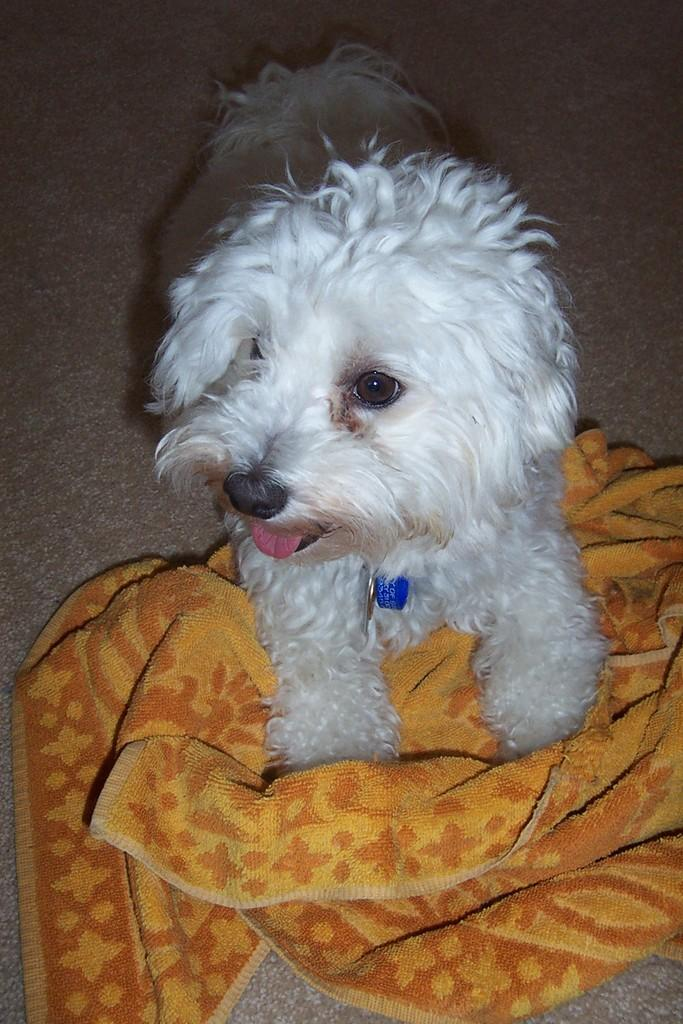What type of animal is present in the image? There is a dog in the image. What type of material is visible in the image? There is cloth visible in the image. What is the surface on which the dog is standing? The ground is visible in the image. What type of fiction is the dog reading in the image? There is no indication in the image that the dog is reading any fiction, as dogs do not read. Can you see any guns in the image? There are no guns present in the image. How many stars are visible in the image? There are no stars visible in the image. 